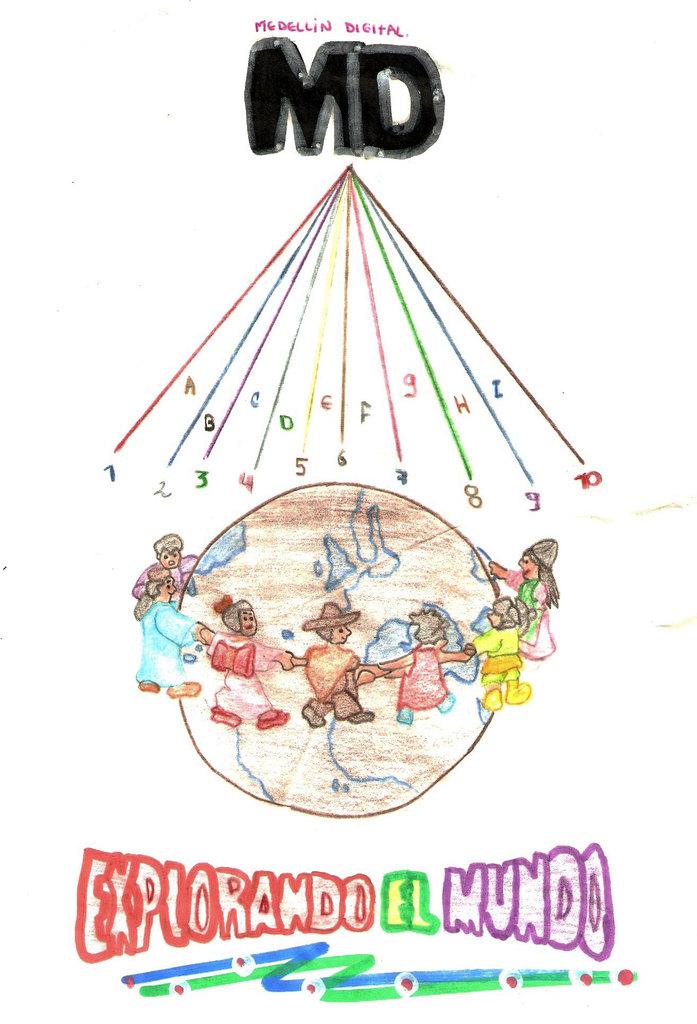What two letters are in black?
Ensure brevity in your answer.  Md. What words are written on the bottom?
Keep it short and to the point. Explorando el mundo. 